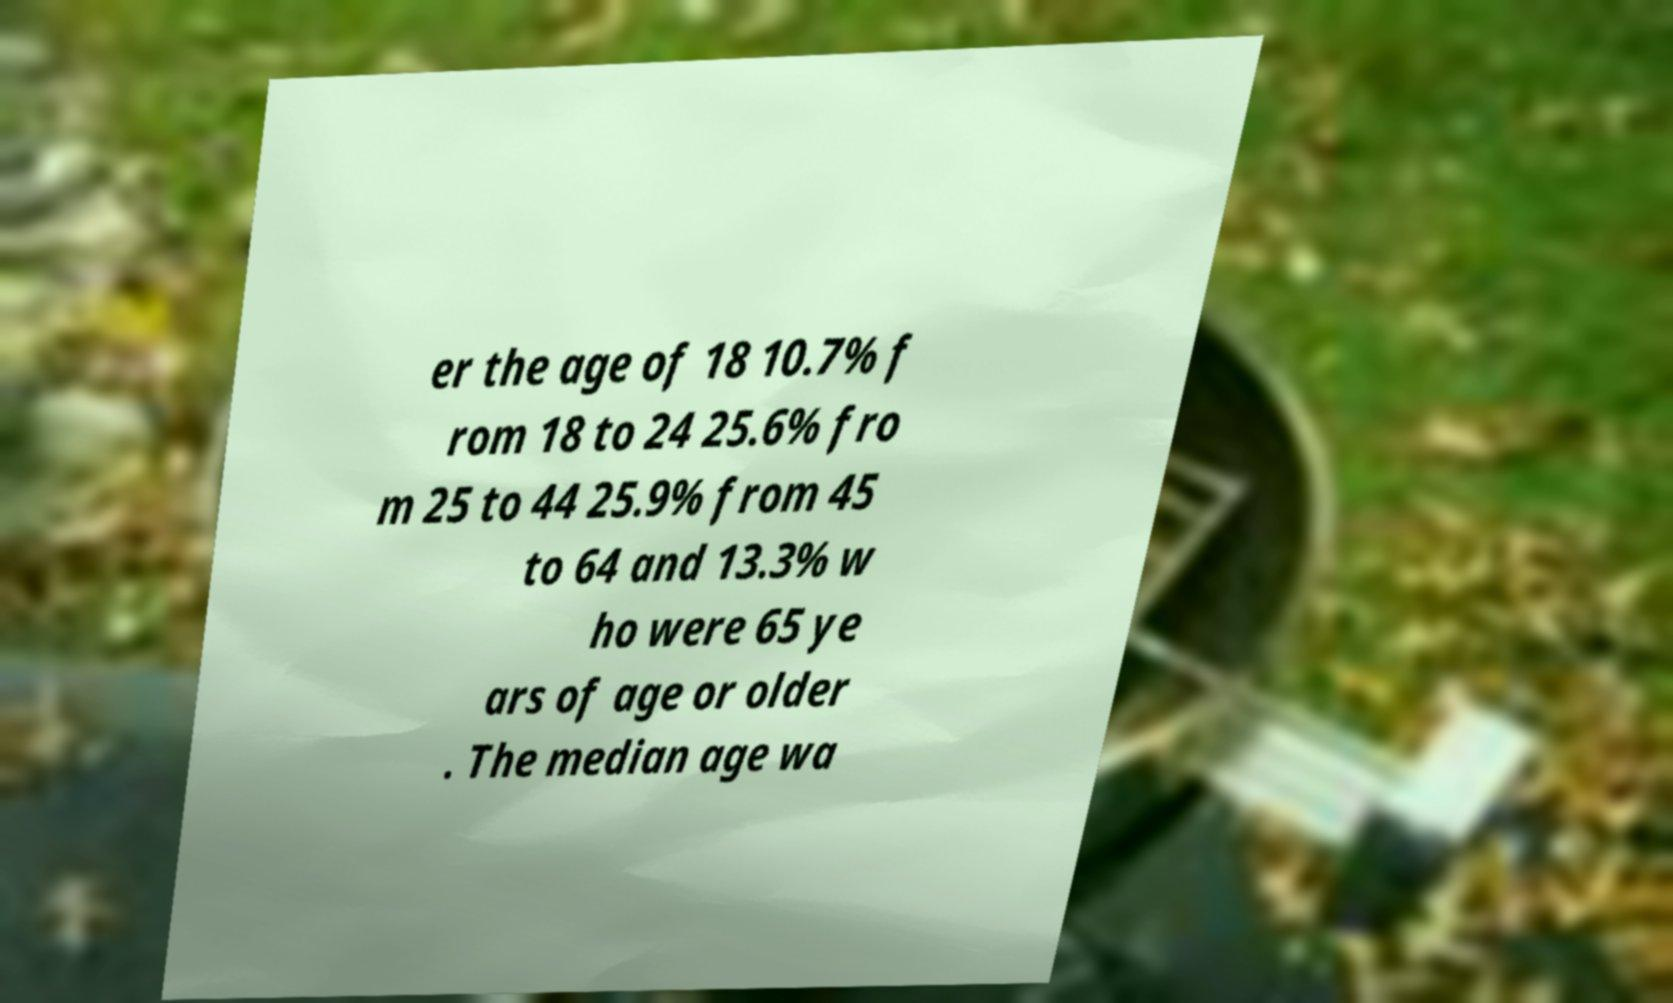I need the written content from this picture converted into text. Can you do that? er the age of 18 10.7% f rom 18 to 24 25.6% fro m 25 to 44 25.9% from 45 to 64 and 13.3% w ho were 65 ye ars of age or older . The median age wa 